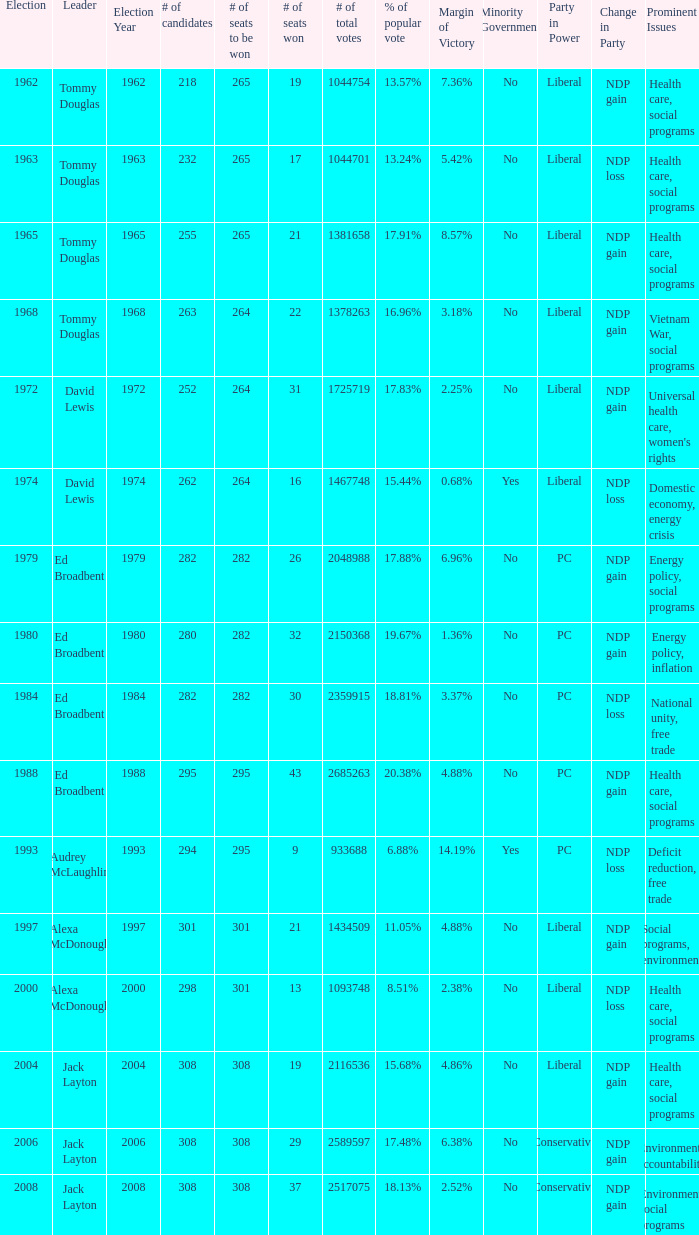Name the number of leaders for % of popular vote being 11.05% 1.0. 